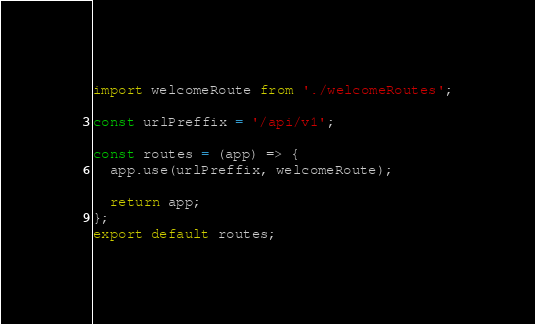Convert code to text. <code><loc_0><loc_0><loc_500><loc_500><_JavaScript_>import welcomeRoute from './welcomeRoutes';

const urlPreffix = '/api/v1';

const routes = (app) => {
  app.use(urlPreffix, welcomeRoute);

  return app;
};
export default routes;
</code> 